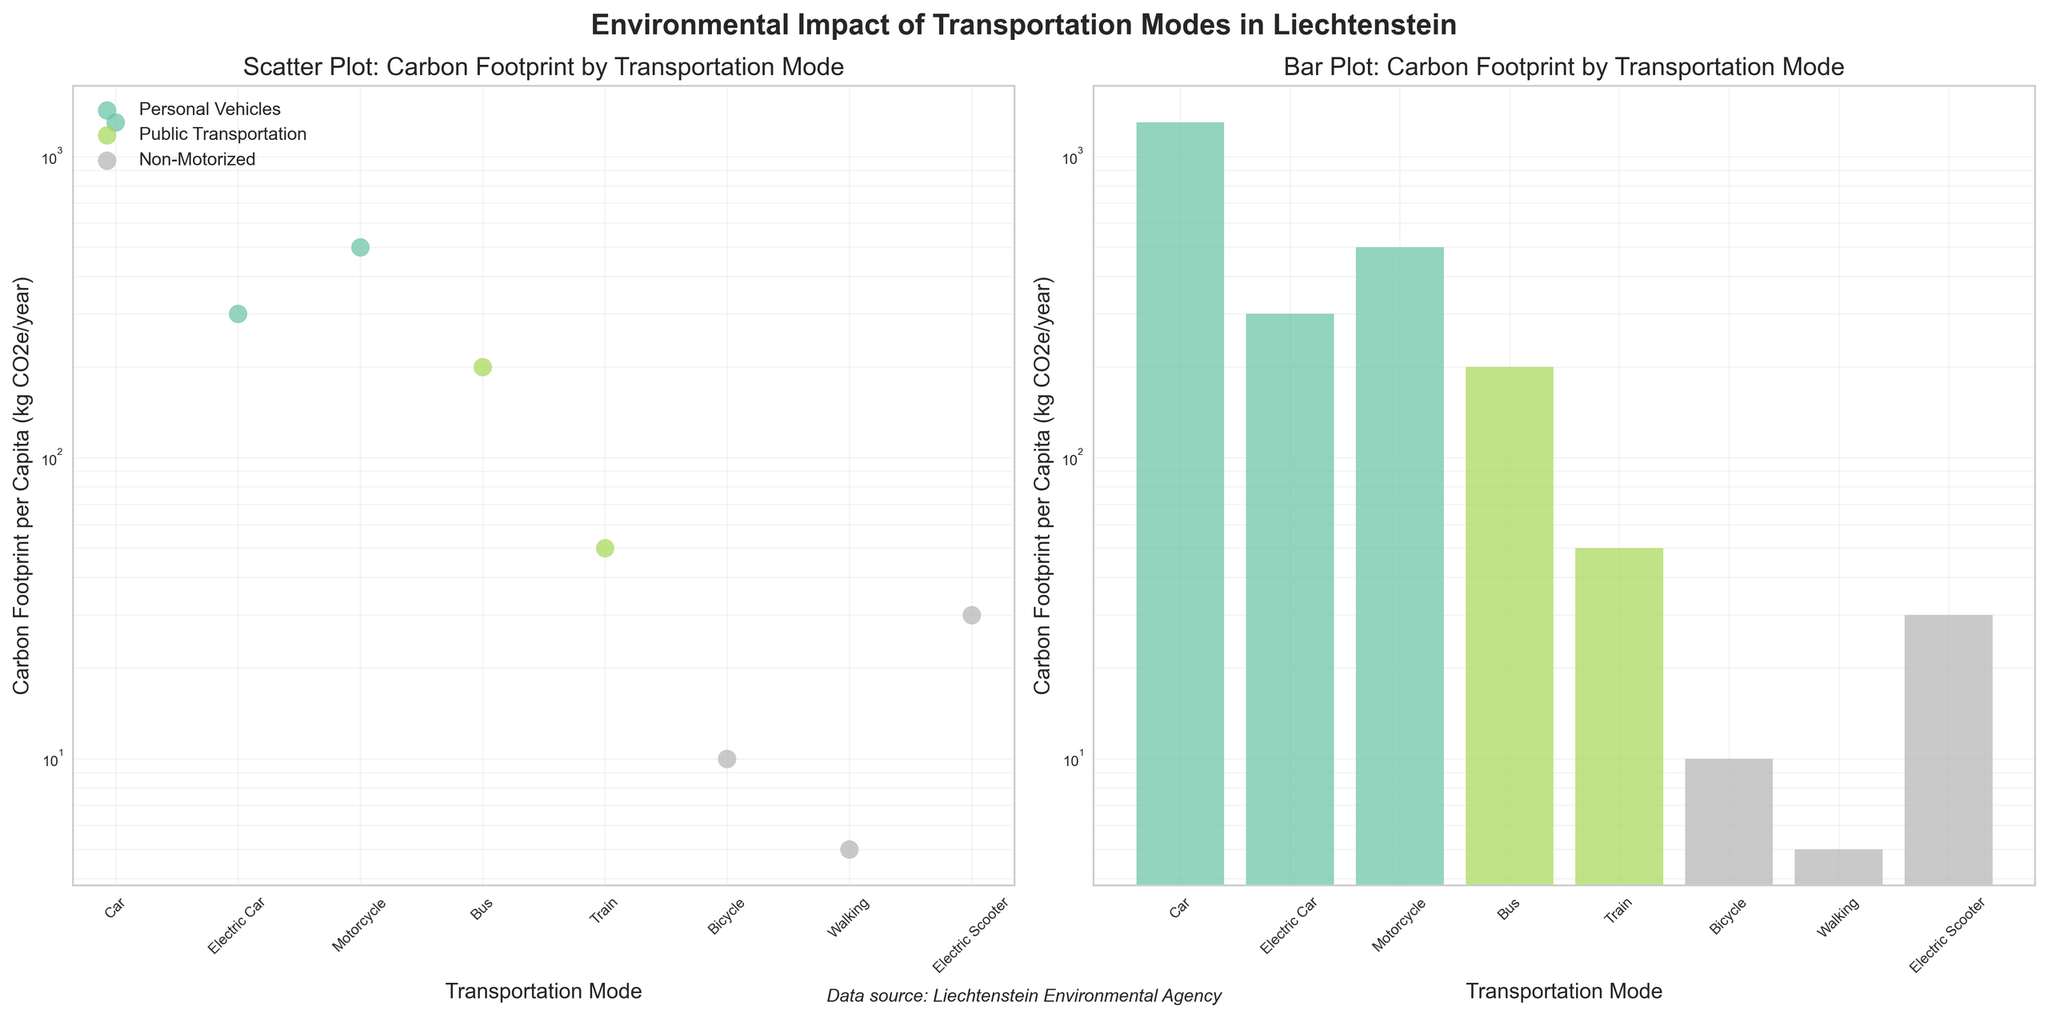what is the title of the left subplot? The left subplot’s title is written at the top of the subplot.
Answer: Scatter Plot: Carbon Footprint by Transportation Mode what are the categories of transportation modes shown in the legend of the left subplot? The legend in the left subplot indicates the categories of transportation modes.
Answer: Personal Vehicles, Public Transportation, Non-Motorized what is the lowest carbon footprint per capita transportation mode? By looking at the bars or dots in both subplots, the lowest value can be identified.
Answer: Walking how many transportation modes fall under the 'Non-Motorized' category? The legend and colored data points/bars indicate that 'Non-Motorized' category includes several transportation modes.
Answer: 3 How does the carbon footprint of a Bus compare to that of a Car? The values for both Bus and Car can be seen from their respective points/bars, showing the difference in their carbon footprints.
Answer: Bus has a lower carbon footprint than Car Which transportation mode in the 'Personal Vehicles' category has the highest carbon footprint? By comparing the 'Personal Vehicles' category data points/bars on the subplots, identify the highest value among them.
Answer: Car How much higher is the carbon footprint of an Electric Car compared to an Electric Scooter? Find the values for both Electric Car and Electric Scooter and calculate the difference between them.
Answer: 270 kg CO2e/year What is the average carbon footprint for Public Transportation modes? Add up the carbon footprint values for the public transportation modes and divide by the number of modes.
Answer: (200 + 50) / 2 = 125 kg CO2e/year For which category are all transportation modes contributing less than 100 kg CO2e/year? Observe the values and categories, and determine whether any category has all transportation modes with values below 100 kg CO2e/year.
Answer: Non-Motorized Which transportation mode has a carbon footprint closest to 500 kg CO2e/year? Looking at the data points/bars and find the mode with a value closest to 500 kg CO2e/year.
Answer: Motorcycle 